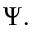<formula> <loc_0><loc_0><loc_500><loc_500>\Psi .</formula> 